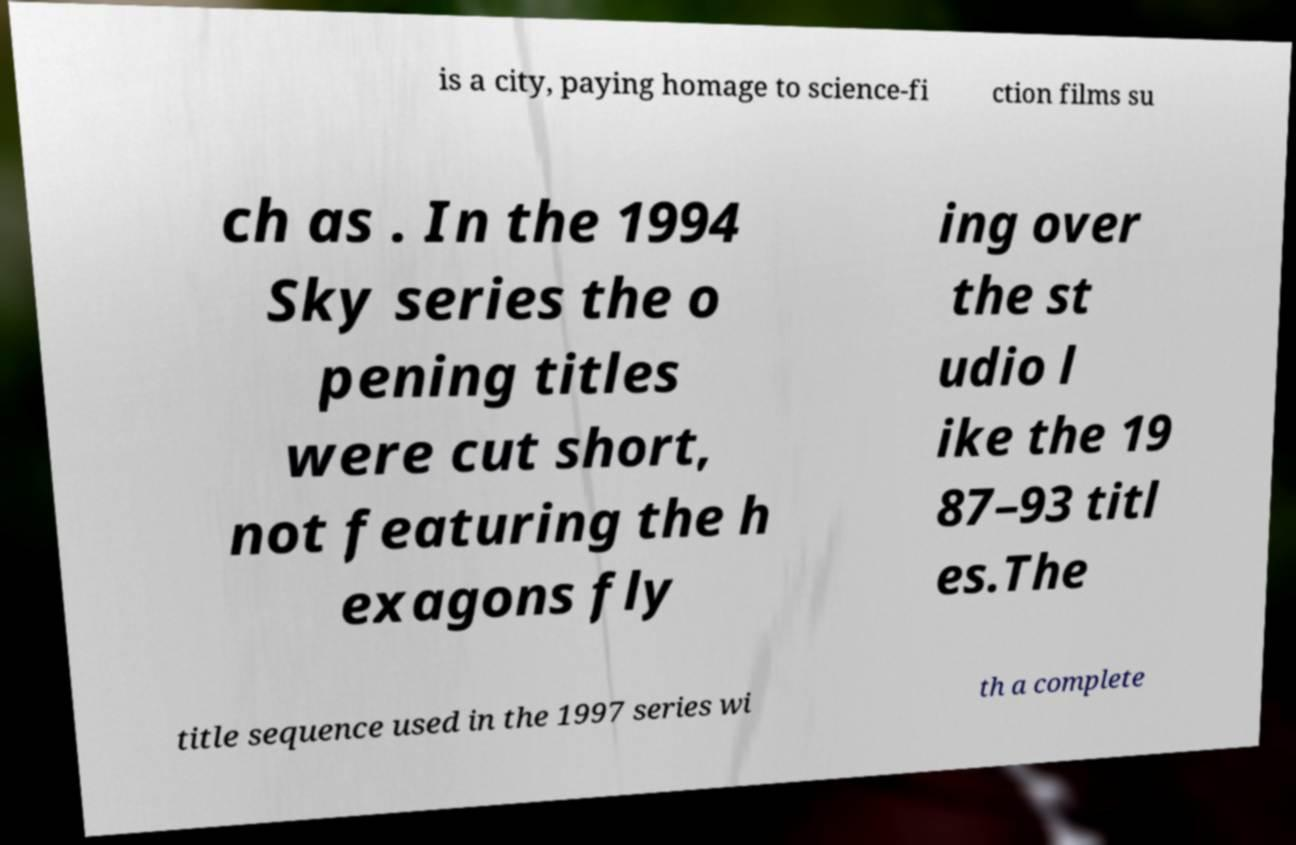There's text embedded in this image that I need extracted. Can you transcribe it verbatim? is a city, paying homage to science-fi ction films su ch as . In the 1994 Sky series the o pening titles were cut short, not featuring the h exagons fly ing over the st udio l ike the 19 87–93 titl es.The title sequence used in the 1997 series wi th a complete 